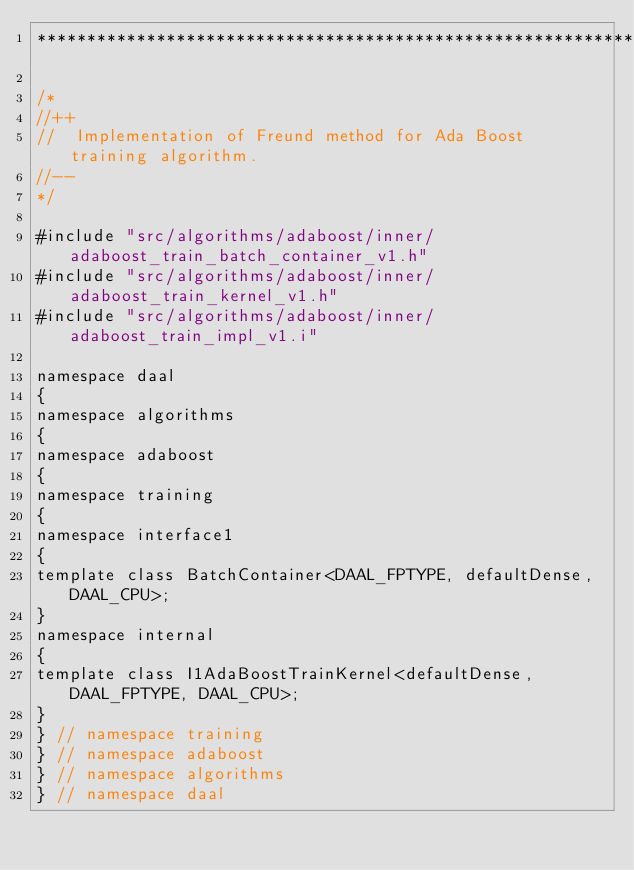<code> <loc_0><loc_0><loc_500><loc_500><_C++_>*******************************************************************************/

/*
//++
//  Implementation of Freund method for Ada Boost training algorithm.
//--
*/

#include "src/algorithms/adaboost/inner/adaboost_train_batch_container_v1.h"
#include "src/algorithms/adaboost/inner/adaboost_train_kernel_v1.h"
#include "src/algorithms/adaboost/inner/adaboost_train_impl_v1.i"

namespace daal
{
namespace algorithms
{
namespace adaboost
{
namespace training
{
namespace interface1
{
template class BatchContainer<DAAL_FPTYPE, defaultDense, DAAL_CPU>;
}
namespace internal
{
template class I1AdaBoostTrainKernel<defaultDense, DAAL_FPTYPE, DAAL_CPU>;
}
} // namespace training
} // namespace adaboost
} // namespace algorithms
} // namespace daal
</code> 